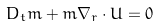<formula> <loc_0><loc_0><loc_500><loc_500>D _ { t } m + m \nabla _ { r } \cdot U = 0</formula> 